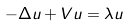Convert formula to latex. <formula><loc_0><loc_0><loc_500><loc_500>- \Delta u + V u = \lambda u</formula> 